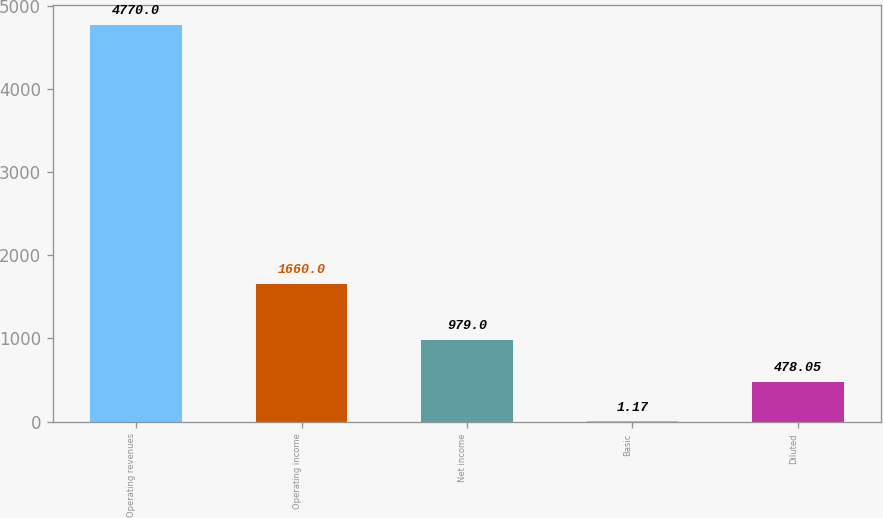Convert chart. <chart><loc_0><loc_0><loc_500><loc_500><bar_chart><fcel>Operating revenues<fcel>Operating income<fcel>Net income<fcel>Basic<fcel>Diluted<nl><fcel>4770<fcel>1660<fcel>979<fcel>1.17<fcel>478.05<nl></chart> 